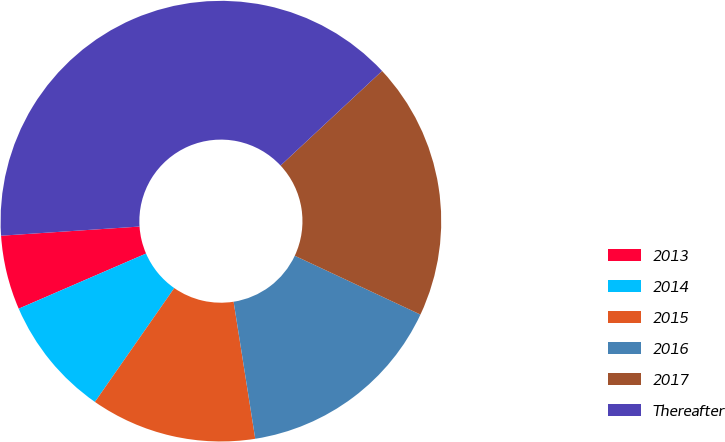<chart> <loc_0><loc_0><loc_500><loc_500><pie_chart><fcel>2013<fcel>2014<fcel>2015<fcel>2016<fcel>2017<fcel>Thereafter<nl><fcel>5.45%<fcel>8.81%<fcel>12.18%<fcel>15.54%<fcel>18.91%<fcel>39.11%<nl></chart> 